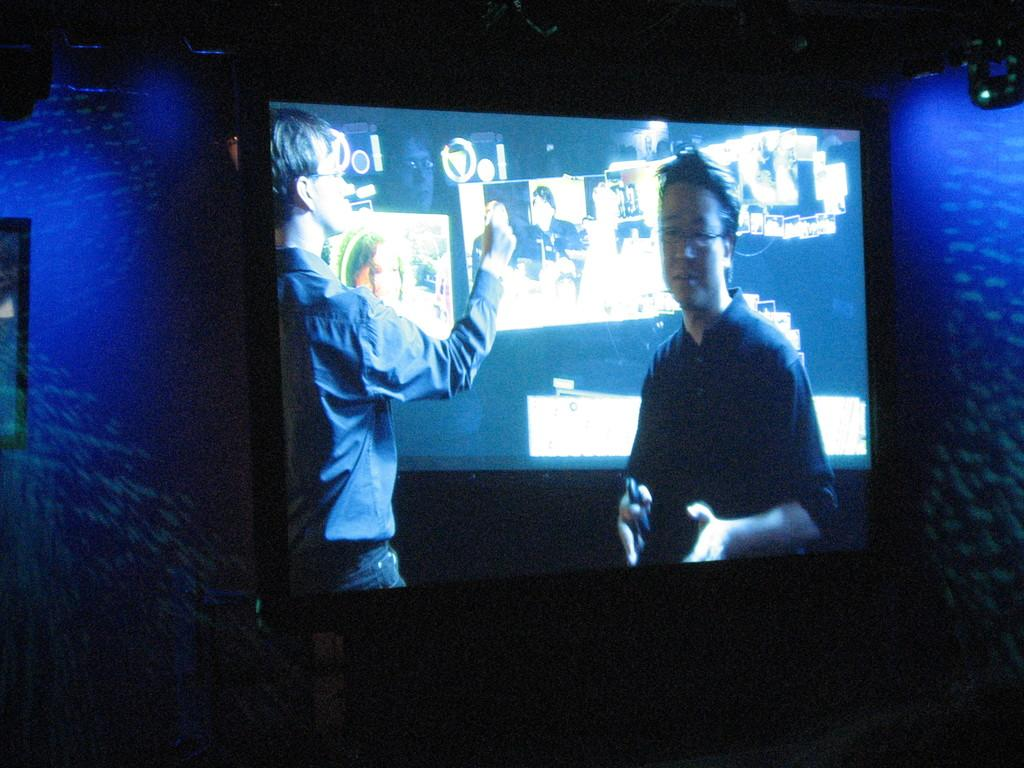What is the main object in the center of the image? There is a television in the center of the image. What can be seen on the right side of the image? There is a light on the right side of the image. What color are the walls on both sides of the image? The wall on the right side of the image is painted blue, and the wall on the left side of the image is also painted blue. What grade does the wristwatch on the television screen receive in the image? There is no wristwatch or any grading system present in the image. 